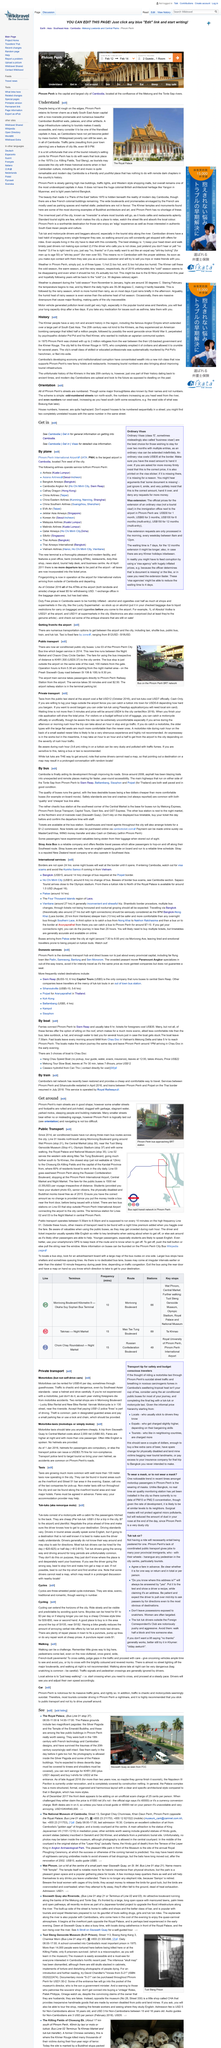Point out several critical features in this image. In Phnom Penh, it is possible to determine if a street runs west-east by observing if the street is even-numbered or odd-numbered. Specifically, streets that are even-numbered indicate that the direction of the street is west-east. In Phnom Penh, it is possible to determine if a street runs north-south by checking if it is odd-numbered. Phnom Penh is renowned for its dark history of the Killing Fields and the infamous Toul Sleng Genocide Museum, which serve as reminders of the atrocities committed during the Cambodian genocide. It is not common for houses in Phnom Penh to be numbered sequentially in their streets, and individuals should not expect this to be the case. The accompanying photo depicts Sisowath Quay as viewed from FCC. 